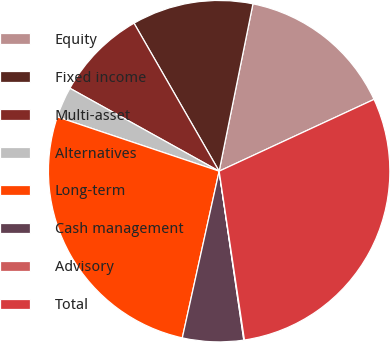Convert chart. <chart><loc_0><loc_0><loc_500><loc_500><pie_chart><fcel>Equity<fcel>Fixed income<fcel>Multi-asset<fcel>Alternatives<fcel>Long-term<fcel>Cash management<fcel>Advisory<fcel>Total<nl><fcel>14.92%<fcel>11.48%<fcel>8.62%<fcel>2.92%<fcel>26.69%<fcel>5.77%<fcel>0.06%<fcel>29.54%<nl></chart> 